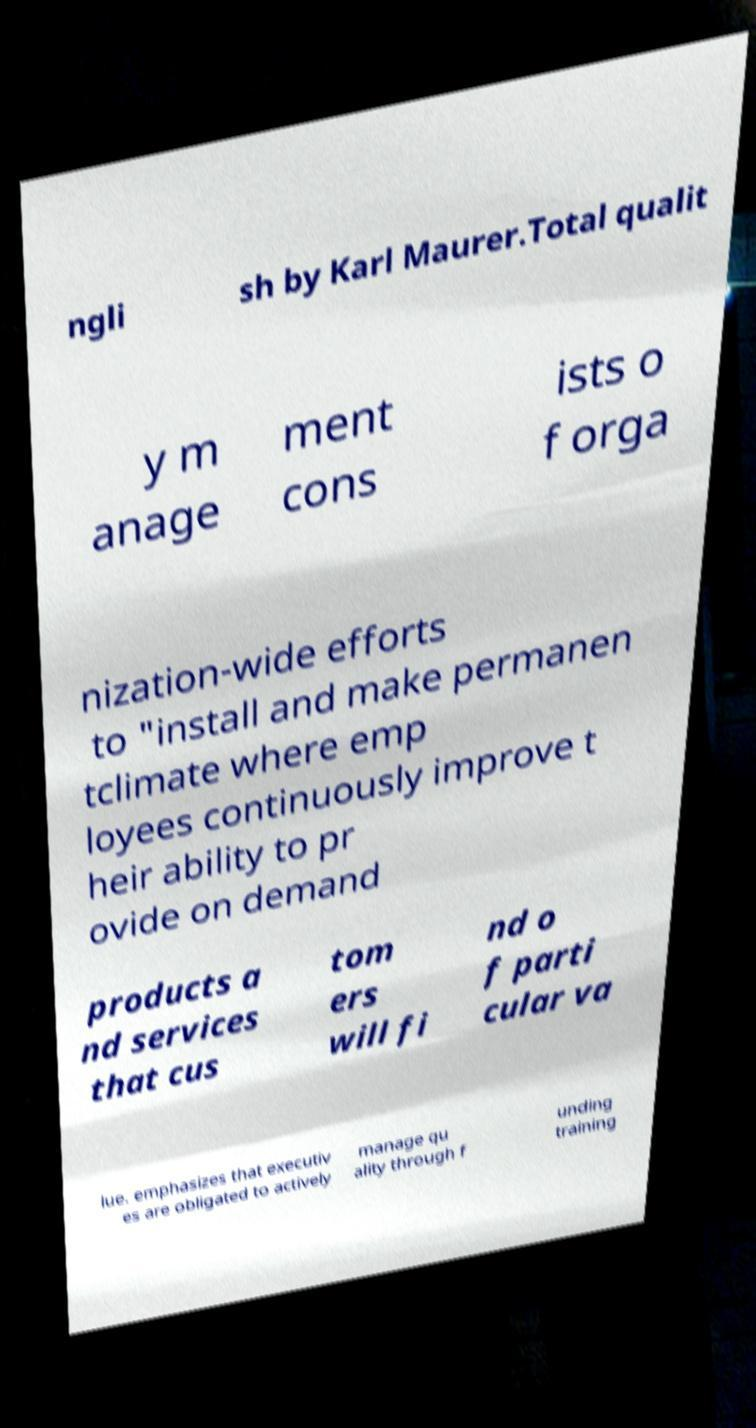Can you accurately transcribe the text from the provided image for me? ngli sh by Karl Maurer.Total qualit y m anage ment cons ists o f orga nization-wide efforts to "install and make permanen tclimate where emp loyees continuously improve t heir ability to pr ovide on demand products a nd services that cus tom ers will fi nd o f parti cular va lue. emphasizes that executiv es are obligated to actively manage qu ality through f unding training 